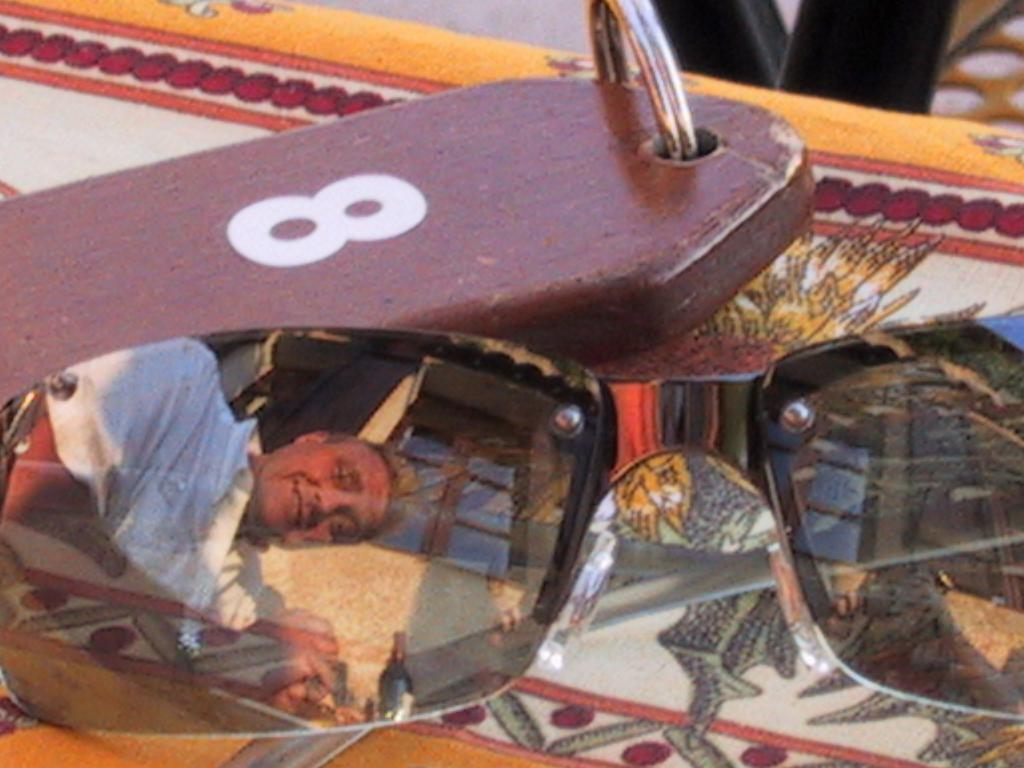What type of objects are present in the image? There are glasses in the image. Can you describe the color of one of the objects? There is a brown color object in the image. What is the appearance of the surface in the image? The surface in the image is colorful. What can be seen in the reflection on the glasses? A person's reflection is visible on the glasses. How many matches are on the colorful surface in the image? There are no matches present in the image. What type of activity are the sisters engaged in on the colorful surface? There are no sisters present in the image, and therefore no such activity can be observed. 